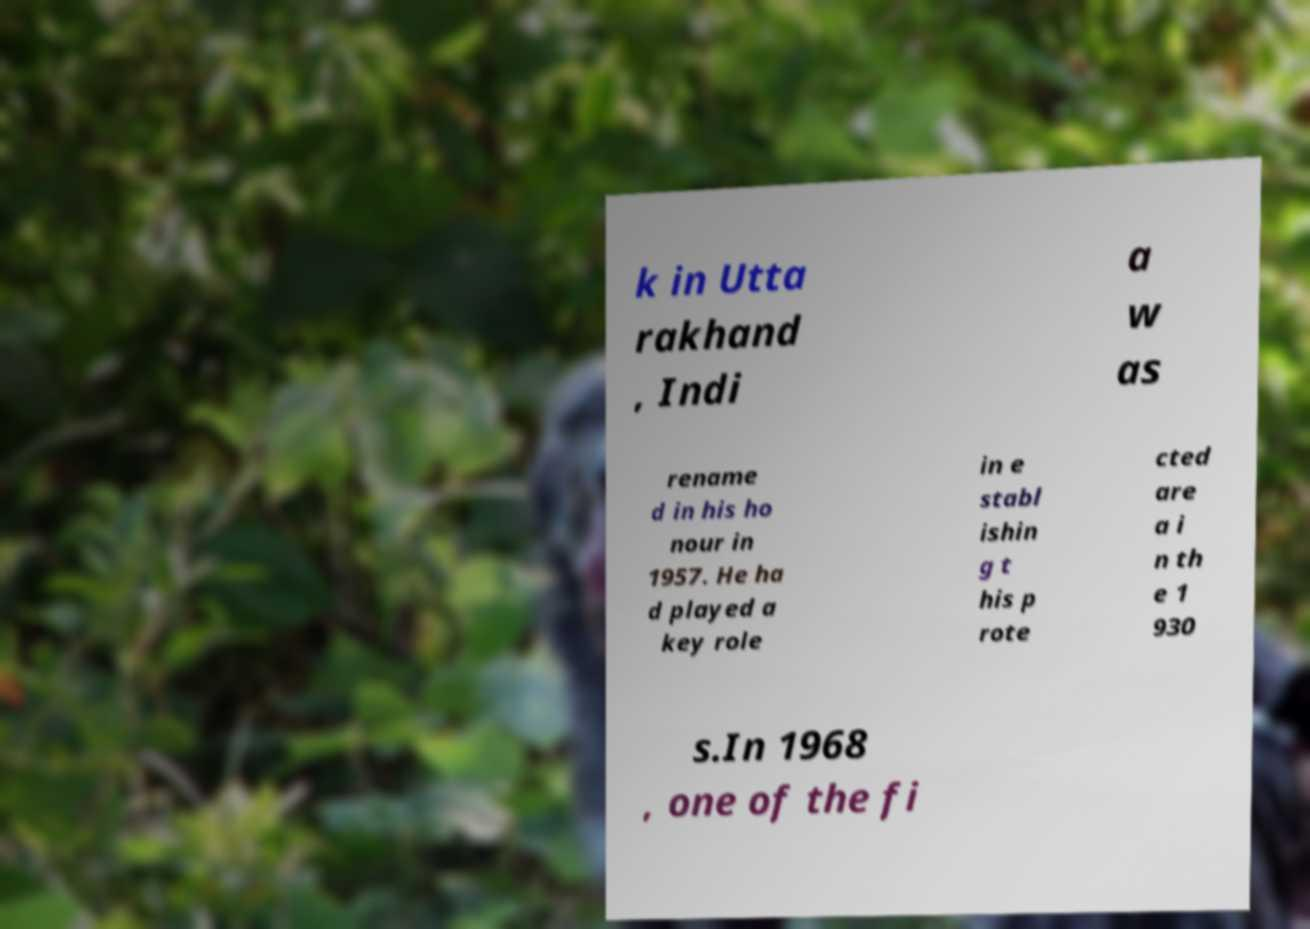Could you extract and type out the text from this image? k in Utta rakhand , Indi a w as rename d in his ho nour in 1957. He ha d played a key role in e stabl ishin g t his p rote cted are a i n th e 1 930 s.In 1968 , one of the fi 